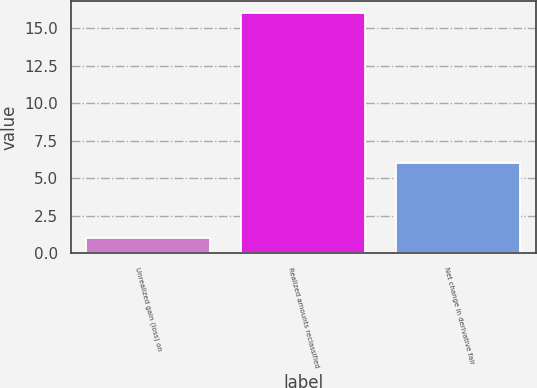Convert chart to OTSL. <chart><loc_0><loc_0><loc_500><loc_500><bar_chart><fcel>Unrealized gain (loss) on<fcel>Realized amounts reclassified<fcel>Net change in derivative fair<nl><fcel>1<fcel>16<fcel>6<nl></chart> 